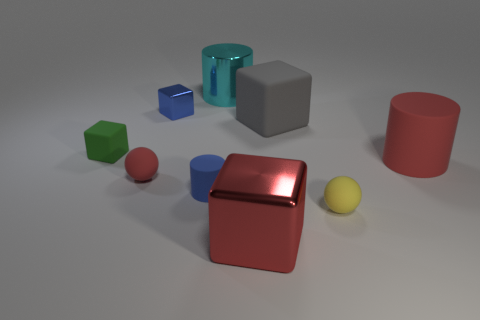What size is the matte cylinder that is the same color as the big metallic cube?
Your response must be concise. Large. What is the material of the sphere that is the same color as the big metal block?
Your answer should be compact. Rubber. There is a tiny yellow object that is the same shape as the tiny red matte thing; what is its material?
Your response must be concise. Rubber. The cyan metal thing that is the same size as the gray matte object is what shape?
Offer a terse response. Cylinder. What number of objects are blue rubber balls or large rubber objects that are right of the gray rubber thing?
Your answer should be compact. 1. Does the large metal block have the same color as the large matte cylinder?
Your response must be concise. Yes. How many big red objects are behind the tiny rubber cube?
Offer a terse response. 0. The other tiny sphere that is made of the same material as the tiny yellow ball is what color?
Your response must be concise. Red. How many rubber things are either big gray cylinders or small spheres?
Your response must be concise. 2. Are the cyan thing and the red cube made of the same material?
Give a very brief answer. Yes. 